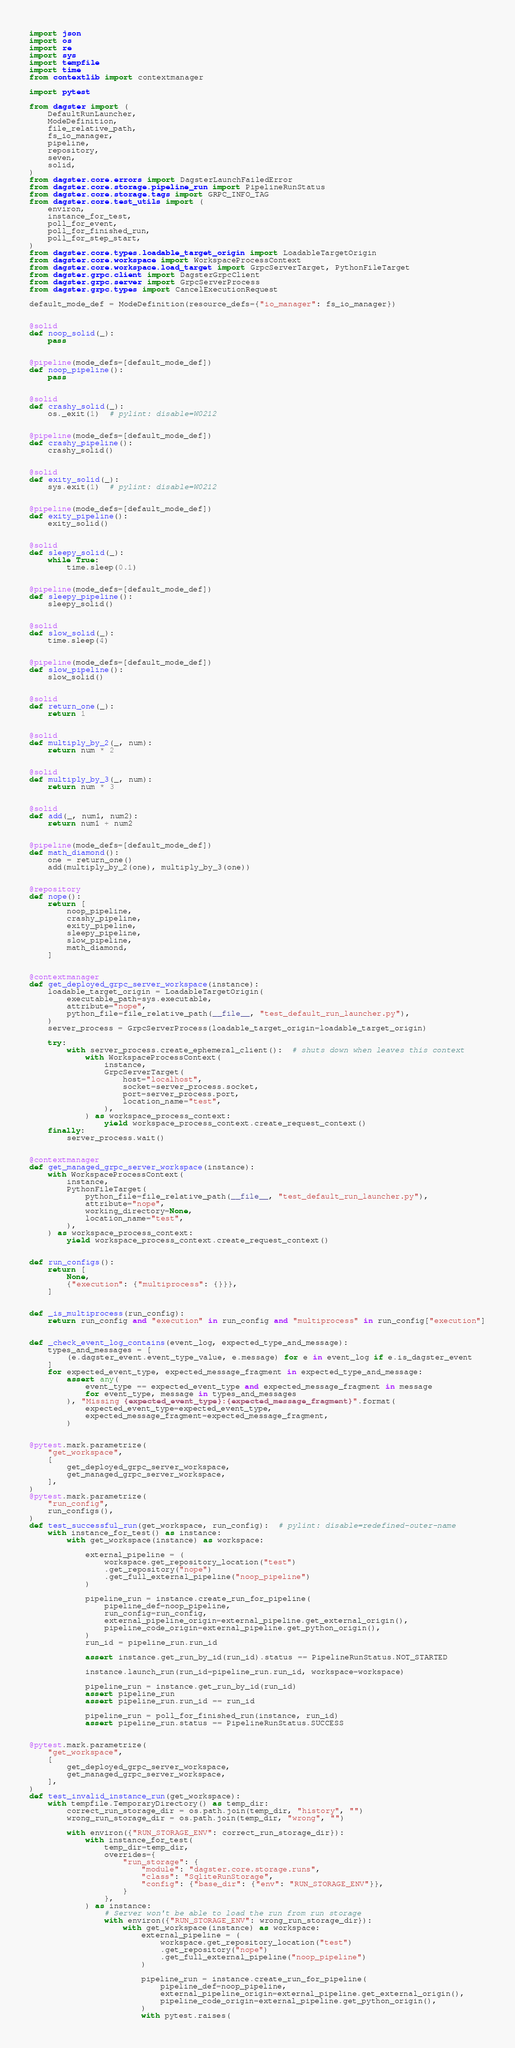Convert code to text. <code><loc_0><loc_0><loc_500><loc_500><_Python_>import json
import os
import re
import sys
import tempfile
import time
from contextlib import contextmanager

import pytest

from dagster import (
    DefaultRunLauncher,
    ModeDefinition,
    file_relative_path,
    fs_io_manager,
    pipeline,
    repository,
    seven,
    solid,
)
from dagster.core.errors import DagsterLaunchFailedError
from dagster.core.storage.pipeline_run import PipelineRunStatus
from dagster.core.storage.tags import GRPC_INFO_TAG
from dagster.core.test_utils import (
    environ,
    instance_for_test,
    poll_for_event,
    poll_for_finished_run,
    poll_for_step_start,
)
from dagster.core.types.loadable_target_origin import LoadableTargetOrigin
from dagster.core.workspace import WorkspaceProcessContext
from dagster.core.workspace.load_target import GrpcServerTarget, PythonFileTarget
from dagster.grpc.client import DagsterGrpcClient
from dagster.grpc.server import GrpcServerProcess
from dagster.grpc.types import CancelExecutionRequest

default_mode_def = ModeDefinition(resource_defs={"io_manager": fs_io_manager})


@solid
def noop_solid(_):
    pass


@pipeline(mode_defs=[default_mode_def])
def noop_pipeline():
    pass


@solid
def crashy_solid(_):
    os._exit(1)  # pylint: disable=W0212


@pipeline(mode_defs=[default_mode_def])
def crashy_pipeline():
    crashy_solid()


@solid
def exity_solid(_):
    sys.exit(1)  # pylint: disable=W0212


@pipeline(mode_defs=[default_mode_def])
def exity_pipeline():
    exity_solid()


@solid
def sleepy_solid(_):
    while True:
        time.sleep(0.1)


@pipeline(mode_defs=[default_mode_def])
def sleepy_pipeline():
    sleepy_solid()


@solid
def slow_solid(_):
    time.sleep(4)


@pipeline(mode_defs=[default_mode_def])
def slow_pipeline():
    slow_solid()


@solid
def return_one(_):
    return 1


@solid
def multiply_by_2(_, num):
    return num * 2


@solid
def multiply_by_3(_, num):
    return num * 3


@solid
def add(_, num1, num2):
    return num1 + num2


@pipeline(mode_defs=[default_mode_def])
def math_diamond():
    one = return_one()
    add(multiply_by_2(one), multiply_by_3(one))


@repository
def nope():
    return [
        noop_pipeline,
        crashy_pipeline,
        exity_pipeline,
        sleepy_pipeline,
        slow_pipeline,
        math_diamond,
    ]


@contextmanager
def get_deployed_grpc_server_workspace(instance):
    loadable_target_origin = LoadableTargetOrigin(
        executable_path=sys.executable,
        attribute="nope",
        python_file=file_relative_path(__file__, "test_default_run_launcher.py"),
    )
    server_process = GrpcServerProcess(loadable_target_origin=loadable_target_origin)

    try:
        with server_process.create_ephemeral_client():  # shuts down when leaves this context
            with WorkspaceProcessContext(
                instance,
                GrpcServerTarget(
                    host="localhost",
                    socket=server_process.socket,
                    port=server_process.port,
                    location_name="test",
                ),
            ) as workspace_process_context:
                yield workspace_process_context.create_request_context()
    finally:
        server_process.wait()


@contextmanager
def get_managed_grpc_server_workspace(instance):
    with WorkspaceProcessContext(
        instance,
        PythonFileTarget(
            python_file=file_relative_path(__file__, "test_default_run_launcher.py"),
            attribute="nope",
            working_directory=None,
            location_name="test",
        ),
    ) as workspace_process_context:
        yield workspace_process_context.create_request_context()


def run_configs():
    return [
        None,
        {"execution": {"multiprocess": {}}},
    ]


def _is_multiprocess(run_config):
    return run_config and "execution" in run_config and "multiprocess" in run_config["execution"]


def _check_event_log_contains(event_log, expected_type_and_message):
    types_and_messages = [
        (e.dagster_event.event_type_value, e.message) for e in event_log if e.is_dagster_event
    ]
    for expected_event_type, expected_message_fragment in expected_type_and_message:
        assert any(
            event_type == expected_event_type and expected_message_fragment in message
            for event_type, message in types_and_messages
        ), "Missing {expected_event_type}:{expected_message_fragment}".format(
            expected_event_type=expected_event_type,
            expected_message_fragment=expected_message_fragment,
        )


@pytest.mark.parametrize(
    "get_workspace",
    [
        get_deployed_grpc_server_workspace,
        get_managed_grpc_server_workspace,
    ],
)
@pytest.mark.parametrize(
    "run_config",
    run_configs(),
)
def test_successful_run(get_workspace, run_config):  # pylint: disable=redefined-outer-name
    with instance_for_test() as instance:
        with get_workspace(instance) as workspace:

            external_pipeline = (
                workspace.get_repository_location("test")
                .get_repository("nope")
                .get_full_external_pipeline("noop_pipeline")
            )

            pipeline_run = instance.create_run_for_pipeline(
                pipeline_def=noop_pipeline,
                run_config=run_config,
                external_pipeline_origin=external_pipeline.get_external_origin(),
                pipeline_code_origin=external_pipeline.get_python_origin(),
            )
            run_id = pipeline_run.run_id

            assert instance.get_run_by_id(run_id).status == PipelineRunStatus.NOT_STARTED

            instance.launch_run(run_id=pipeline_run.run_id, workspace=workspace)

            pipeline_run = instance.get_run_by_id(run_id)
            assert pipeline_run
            assert pipeline_run.run_id == run_id

            pipeline_run = poll_for_finished_run(instance, run_id)
            assert pipeline_run.status == PipelineRunStatus.SUCCESS


@pytest.mark.parametrize(
    "get_workspace",
    [
        get_deployed_grpc_server_workspace,
        get_managed_grpc_server_workspace,
    ],
)
def test_invalid_instance_run(get_workspace):
    with tempfile.TemporaryDirectory() as temp_dir:
        correct_run_storage_dir = os.path.join(temp_dir, "history", "")
        wrong_run_storage_dir = os.path.join(temp_dir, "wrong", "")

        with environ({"RUN_STORAGE_ENV": correct_run_storage_dir}):
            with instance_for_test(
                temp_dir=temp_dir,
                overrides={
                    "run_storage": {
                        "module": "dagster.core.storage.runs",
                        "class": "SqliteRunStorage",
                        "config": {"base_dir": {"env": "RUN_STORAGE_ENV"}},
                    }
                },
            ) as instance:
                # Server won't be able to load the run from run storage
                with environ({"RUN_STORAGE_ENV": wrong_run_storage_dir}):
                    with get_workspace(instance) as workspace:
                        external_pipeline = (
                            workspace.get_repository_location("test")
                            .get_repository("nope")
                            .get_full_external_pipeline("noop_pipeline")
                        )

                        pipeline_run = instance.create_run_for_pipeline(
                            pipeline_def=noop_pipeline,
                            external_pipeline_origin=external_pipeline.get_external_origin(),
                            pipeline_code_origin=external_pipeline.get_python_origin(),
                        )
                        with pytest.raises(</code> 